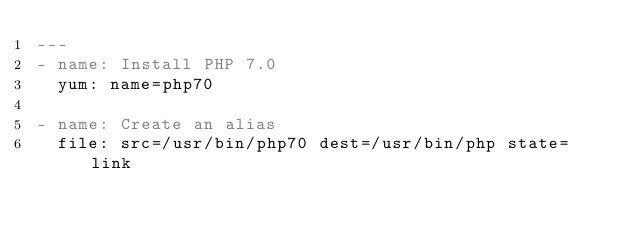<code> <loc_0><loc_0><loc_500><loc_500><_YAML_>---
- name: Install PHP 7.0
  yum: name=php70

- name: Create an alias
  file: src=/usr/bin/php70 dest=/usr/bin/php state=link
</code> 